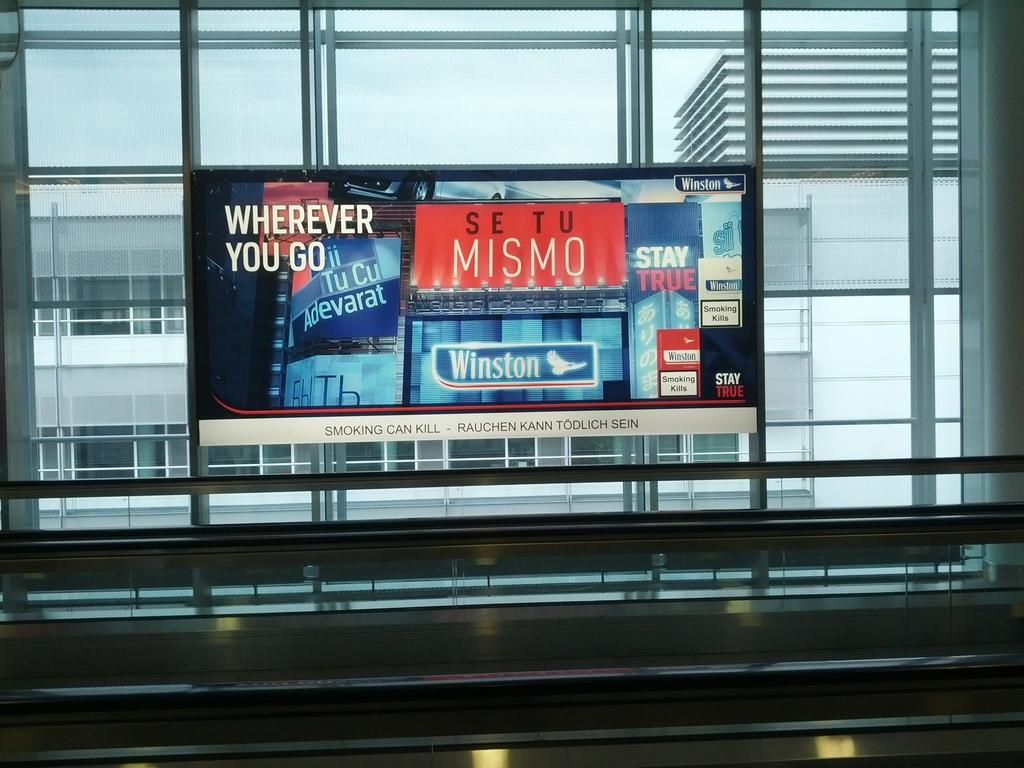Provide a one-sentence caption for the provided image. some ads on a window that say WHEREEVER YOU GO, MISMO and Winston. 